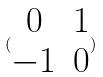Convert formula to latex. <formula><loc_0><loc_0><loc_500><loc_500>( \begin{matrix} 0 & 1 \\ - 1 & 0 \end{matrix} )</formula> 